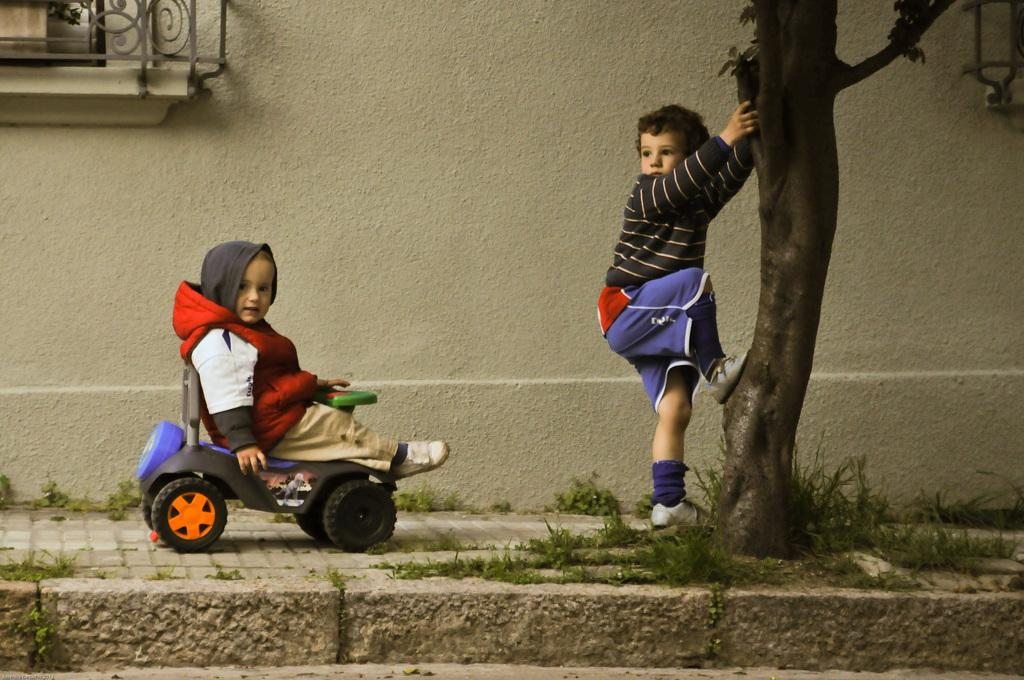How many kids are present in the image? There are two kids in the image. What are the positions of the kids in the image? One kid is standing, and the other kid is sitting in a toy car. What can be seen in the background of the image? There is a wall in the background of the image. What type of pie is the kid in the toy car eating in the image? There is no pie present in the image; the kids are not eating anything. 